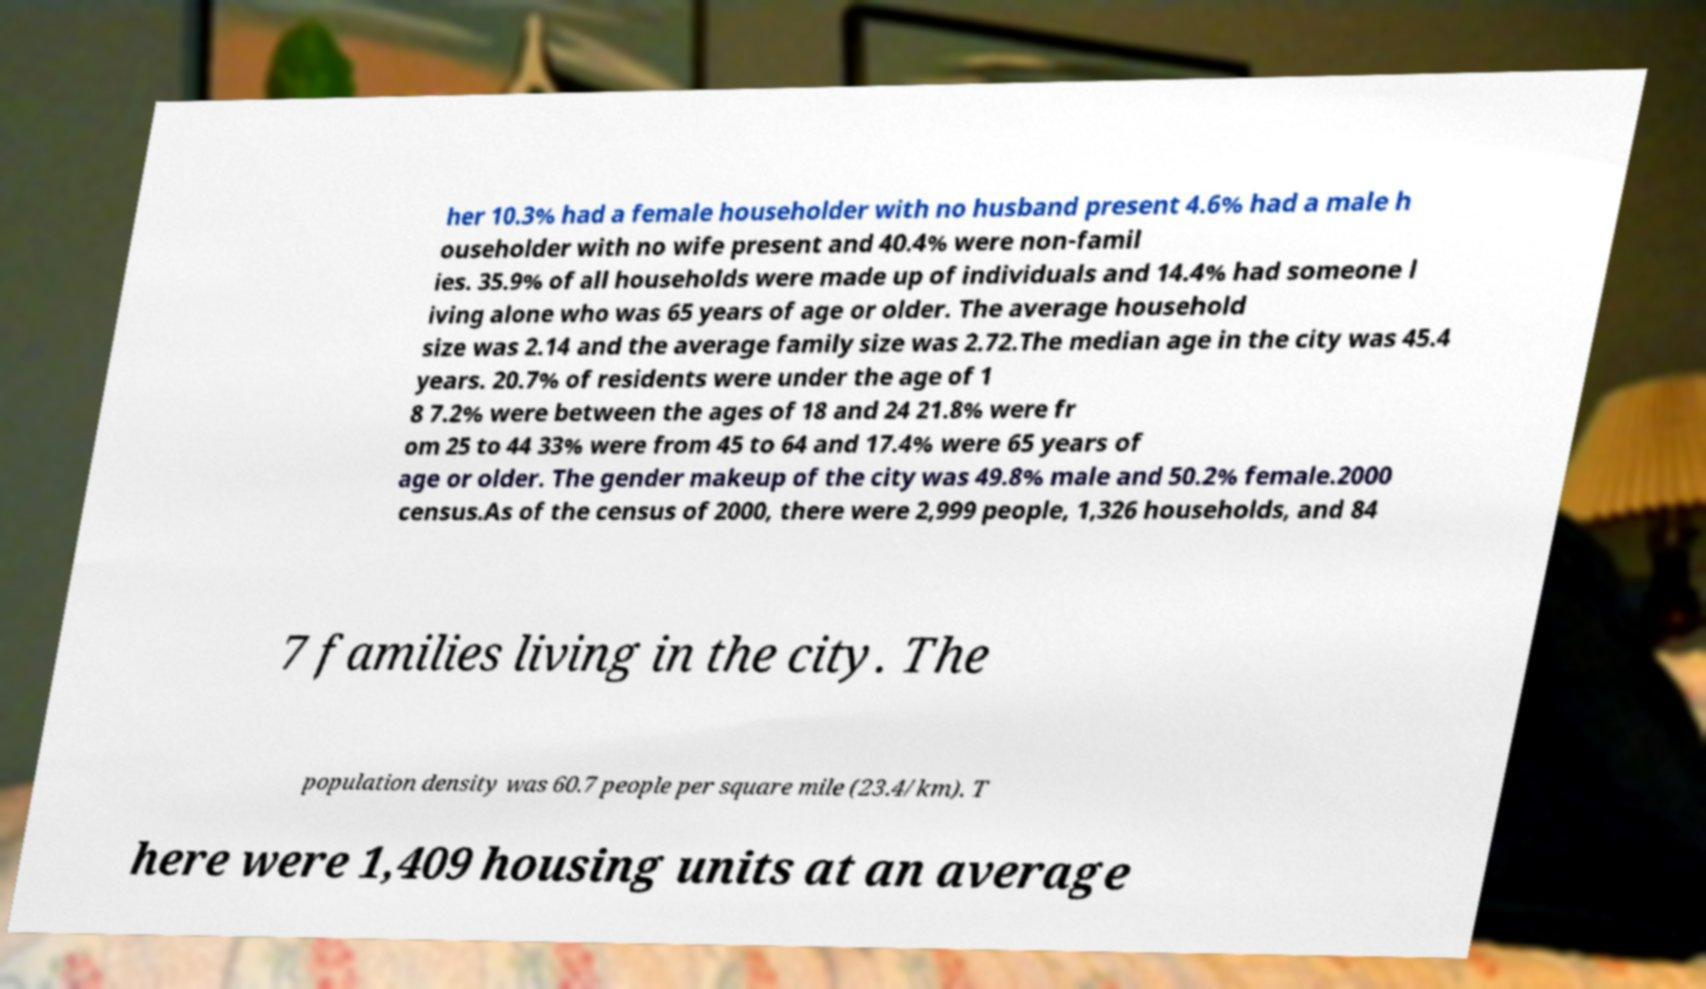What messages or text are displayed in this image? I need them in a readable, typed format. her 10.3% had a female householder with no husband present 4.6% had a male h ouseholder with no wife present and 40.4% were non-famil ies. 35.9% of all households were made up of individuals and 14.4% had someone l iving alone who was 65 years of age or older. The average household size was 2.14 and the average family size was 2.72.The median age in the city was 45.4 years. 20.7% of residents were under the age of 1 8 7.2% were between the ages of 18 and 24 21.8% were fr om 25 to 44 33% were from 45 to 64 and 17.4% were 65 years of age or older. The gender makeup of the city was 49.8% male and 50.2% female.2000 census.As of the census of 2000, there were 2,999 people, 1,326 households, and 84 7 families living in the city. The population density was 60.7 people per square mile (23.4/km). T here were 1,409 housing units at an average 